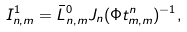<formula> <loc_0><loc_0><loc_500><loc_500>I ^ { 1 } _ { n , m } = \bar { L } _ { n , m } ^ { 0 } J _ { n } ( \Phi t _ { m , m } ^ { n } ) ^ { - 1 } ,</formula> 